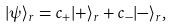<formula> <loc_0><loc_0><loc_500><loc_500>| \psi \rangle _ { r } = c _ { + } | + \rangle _ { r } + c _ { - } | - \rangle _ { r } ,</formula> 